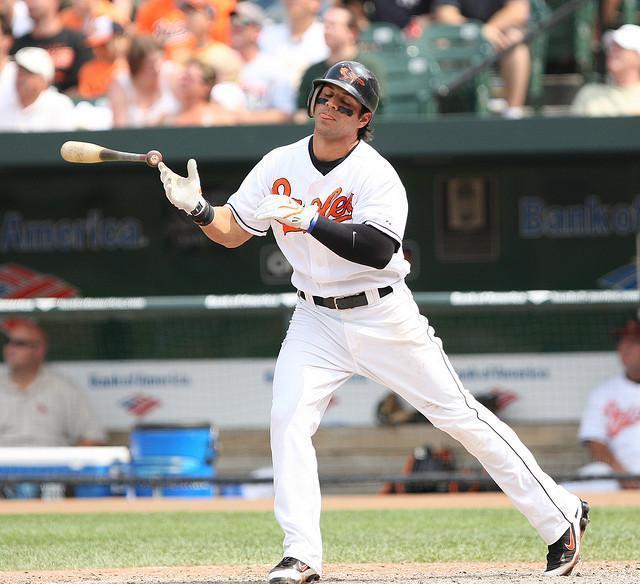How many people are in the photo?
Give a very brief answer. 13. 